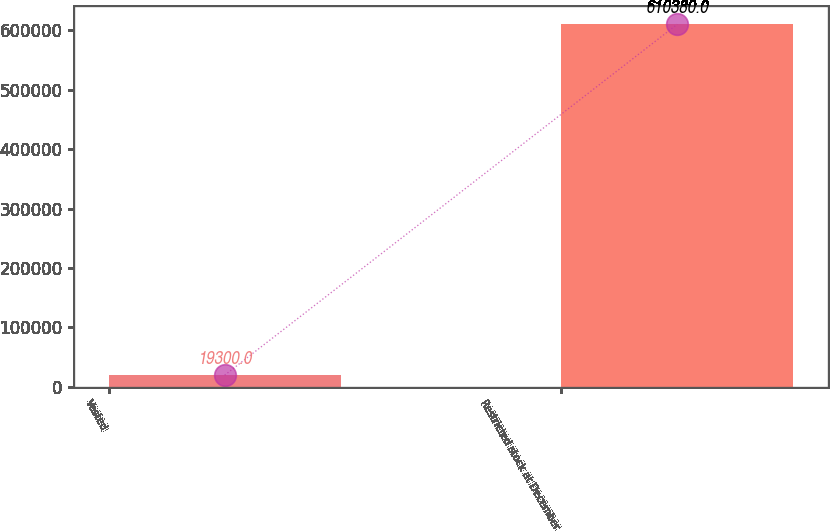<chart> <loc_0><loc_0><loc_500><loc_500><bar_chart><fcel>Vested<fcel>Restricted stock at December<nl><fcel>19300<fcel>610380<nl></chart> 